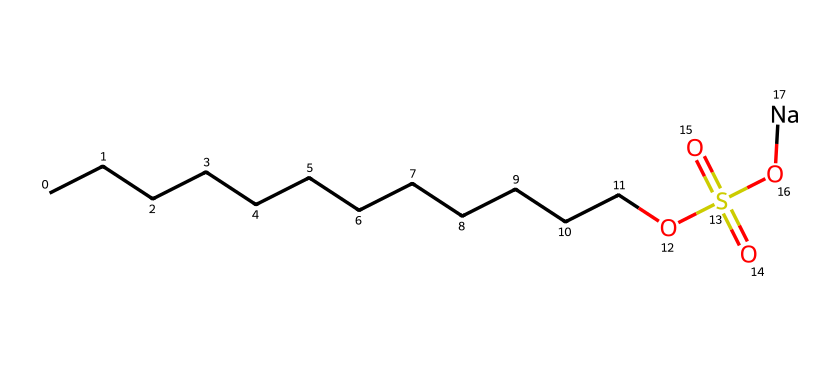What is the length of the carbon chain in this molecule? The chemical structure contains a straight chain of carbon atoms, specifically indicated by "CCCCCCCCCCCC", which represents 12 carbon atoms in total.
Answer: 12 How many oxygen atoms are present in this chemical? By analyzing the chemical formula, there are three oxygen atoms: one in the sulfonate group (OS(=O)(=O)O) and one in the terminal hydroxyl group.
Answer: 3 What type of surfactant is indicated by this structure? This structure contains a long hydrophobic carbon chain and a hydrophilic sulfonate group, classifying it as an anionic surfactant.
Answer: anionic What is the significance of the sulfonate group in the structure? The sulfonate group (OS(=O)(=O)O) enhances the water-solubility of the molecule, making it effective as a surfactant in cleaning applications.
Answer: enhances water-solubility Does this molecule indicate biodegradability? Yes, the presence of a long carbon chain and a polar functional group suggests it is a biodegradable surfactant due to its natural breakdown potential in the environment.
Answer: yes What is the role of the sodium (Na) in this surfactant? The sodium is present to form a salt with the sulfonate group, helping to stabilize the molecule in aqueous solutions and improving its solubility.
Answer: stabilizing agent What functional groups are present in this chemical? The chemical contains a sulfonate functional group and a hydroxyl group, contributing to its surfactant properties and overall solubility.
Answer: sulfonate and hydroxyl 